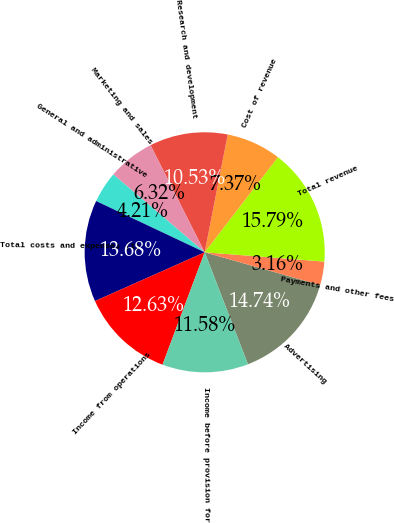<chart> <loc_0><loc_0><loc_500><loc_500><pie_chart><fcel>Advertising<fcel>Payments and other fees<fcel>Total revenue<fcel>Cost of revenue<fcel>Research and development<fcel>Marketing and sales<fcel>General and administrative<fcel>Total costs and expenses (1)<fcel>Income from operations<fcel>Income before provision for<nl><fcel>14.74%<fcel>3.16%<fcel>15.79%<fcel>7.37%<fcel>10.53%<fcel>6.32%<fcel>4.21%<fcel>13.68%<fcel>12.63%<fcel>11.58%<nl></chart> 